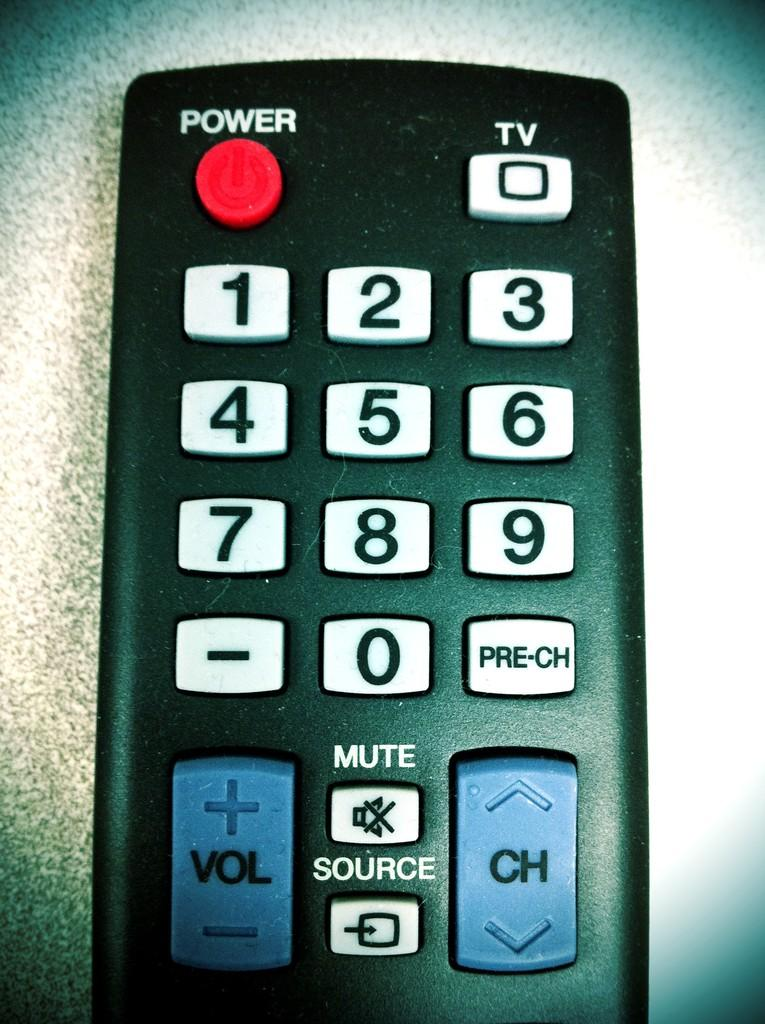<image>
Write a terse but informative summary of the picture. a black remote control to a television with white keys and blue volume and channel buttons. 